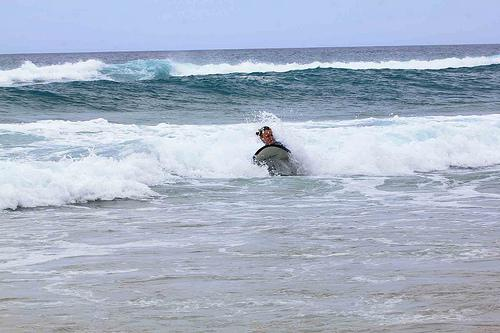Question: when was the picture taken?
Choices:
A. Evening.
B. Night.
C. During the day.
D. Morning.
Answer with the letter. Answer: C Question: where was the picture taken?
Choices:
A. Mountains.
B. At the beach.
C. Yard.
D. Inside.
Answer with the letter. Answer: B Question: who is in the picture?
Choices:
A. Dog.
B. A man.
C. Woman.
D. Dad.
Answer with the letter. Answer: B Question: what is the man on?
Choices:
A. A surfboard.
B. Ground.
C. Platform.
D. Stage.
Answer with the letter. Answer: A Question: what part of the man is showing in the picture?
Choices:
A. His head.
B. Feet.
C. Waste.
D. Eyes.
Answer with the letter. Answer: A Question: why was the picture taken?
Choices:
A. To catch the hit.
B. To see him shoot.
C. Portrait.
D. To capture the man surfing.
Answer with the letter. Answer: D 